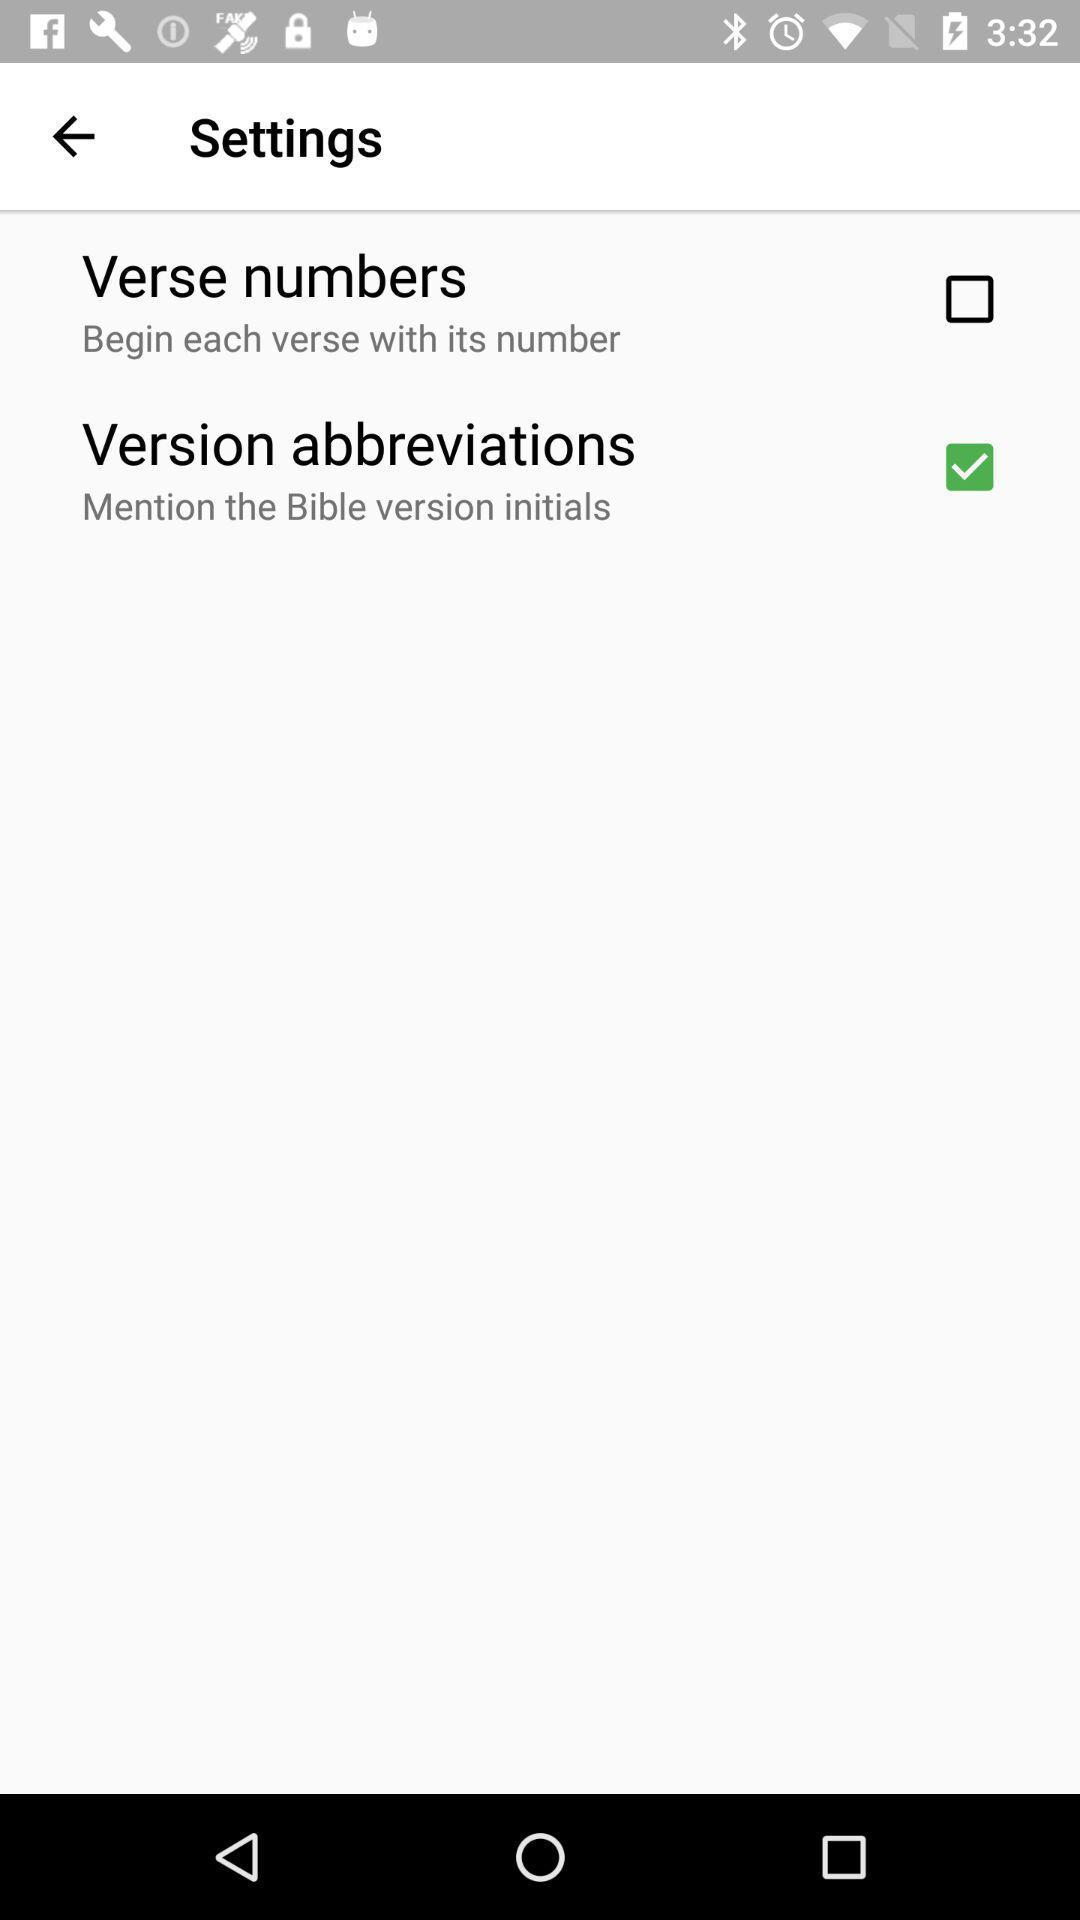What is the status of the "Version abbreviations"? The status is "on". 